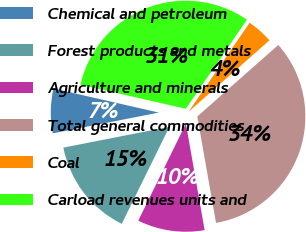<chart> <loc_0><loc_0><loc_500><loc_500><pie_chart><fcel>Chemical and petroleum<fcel>Forest products and metals<fcel>Agriculture and minerals<fcel>Total general commodities<fcel>Coal<fcel>Carload revenues units and<nl><fcel>6.65%<fcel>14.65%<fcel>10.04%<fcel>33.74%<fcel>3.91%<fcel>31.0%<nl></chart> 